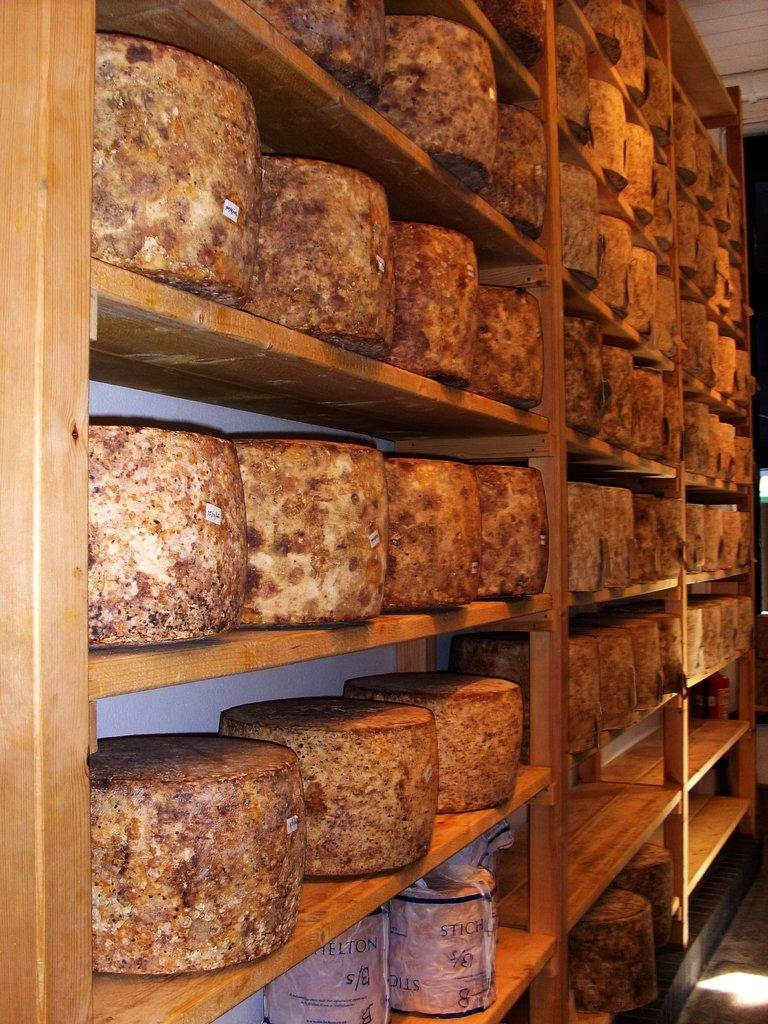What type of furniture is present in the image? There is a cupboard in the image. What is stored inside the cupboard? The cupboard contains blocks of cheese. Are there any other items stored in the cupboard besides cheese? Yes, there are other things arranged in the cupboard. Is there a lamp hanging above the cupboard in the image? There is no mention of a lamp in the image, so we cannot confirm its presence. 